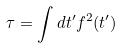Convert formula to latex. <formula><loc_0><loc_0><loc_500><loc_500>\tau = \int d t ^ { \prime } f ^ { 2 } ( t ^ { \prime } )</formula> 